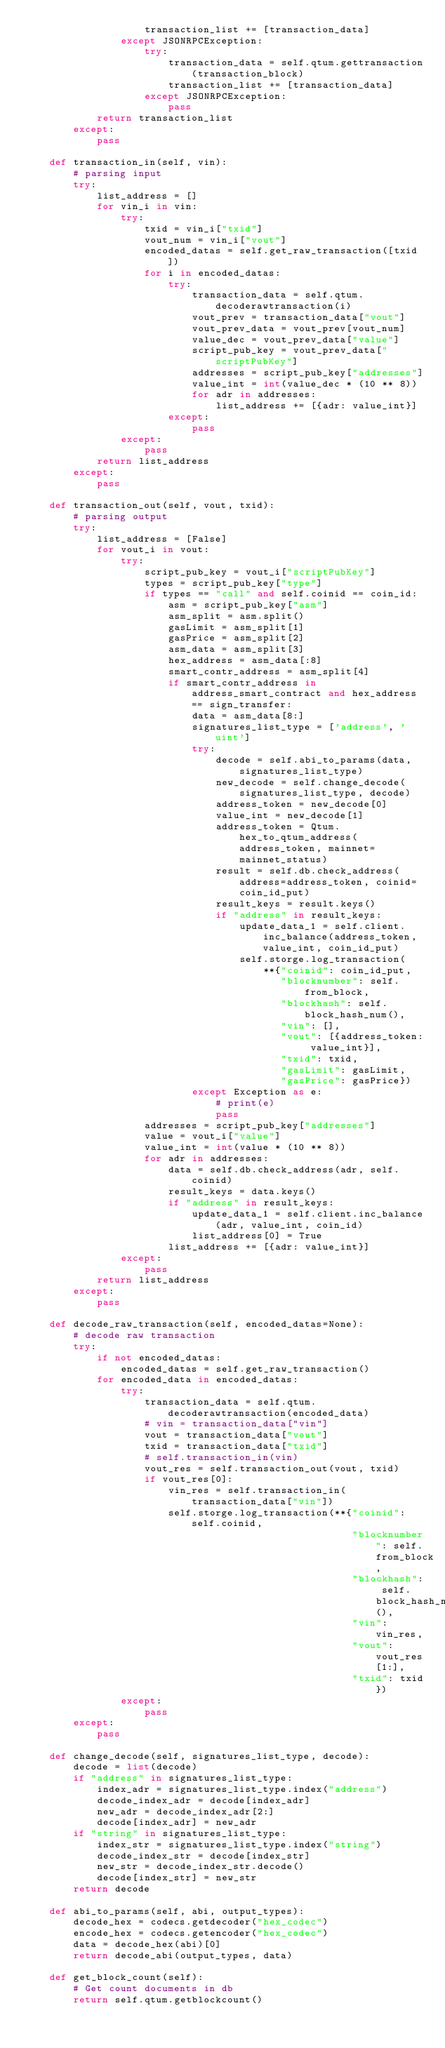<code> <loc_0><loc_0><loc_500><loc_500><_Python_>                    transaction_list += [transaction_data]
                except JSONRPCException:
                    try:
                        transaction_data = self.qtum.gettransaction(transaction_block)
                        transaction_list += [transaction_data]
                    except JSONRPCException:
                        pass
            return transaction_list
        except:
            pass

    def transaction_in(self, vin):
        # parsing input
        try:
            list_address = []
            for vin_i in vin:
                try:
                    txid = vin_i["txid"]
                    vout_num = vin_i["vout"]
                    encoded_datas = self.get_raw_transaction([txid])
                    for i in encoded_datas:
                        try:
                            transaction_data = self.qtum.decoderawtransaction(i)
                            vout_prev = transaction_data["vout"]
                            vout_prev_data = vout_prev[vout_num]
                            value_dec = vout_prev_data["value"]
                            script_pub_key = vout_prev_data["scriptPubKey"]
                            addresses = script_pub_key["addresses"]
                            value_int = int(value_dec * (10 ** 8))
                            for adr in addresses:
                                list_address += [{adr: value_int}]
                        except:
                            pass
                except:
                    pass
            return list_address
        except:
            pass

    def transaction_out(self, vout, txid):
        # parsing output
        try:
            list_address = [False]
            for vout_i in vout:
                try:
                    script_pub_key = vout_i["scriptPubKey"]
                    types = script_pub_key["type"]
                    if types == "call" and self.coinid == coin_id:
                        asm = script_pub_key["asm"]
                        asm_split = asm.split()
                        gasLimit = asm_split[1]
                        gasPrice = asm_split[2]
                        asm_data = asm_split[3]
                        hex_address = asm_data[:8]
                        smart_contr_address = asm_split[4]
                        if smart_contr_address in address_smart_contract and hex_address == sign_transfer:
                            data = asm_data[8:]
                            signatures_list_type = ['address', 'uint']
                            try:
                                decode = self.abi_to_params(data, signatures_list_type)
                                new_decode = self.change_decode(signatures_list_type, decode)
                                address_token = new_decode[0]
                                value_int = new_decode[1]
                                address_token = Qtum.hex_to_qtum_address(address_token, mainnet=mainnet_status)
                                result = self.db.check_address(address=address_token, coinid=coin_id_put)
                                result_keys = result.keys()
                                if "address" in result_keys:
                                    update_data_1 = self.client.inc_balance(address_token, value_int, coin_id_put)
                                    self.storge.log_transaction(
                                        **{"coinid": coin_id_put,
                                           "blocknumber": self.from_block,
                                           "blockhash": self.block_hash_num(),
                                           "vin": [],
                                           "vout": [{address_token: value_int}],
                                           "txid": txid,
                                           "gasLimit": gasLimit,
                                           "gasPrice": gasPrice})
                            except Exception as e:
                                # print(e)
                                pass
                    addresses = script_pub_key["addresses"]
                    value = vout_i["value"]
                    value_int = int(value * (10 ** 8))
                    for adr in addresses:
                        data = self.db.check_address(adr, self.coinid)
                        result_keys = data.keys()
                        if "address" in result_keys:
                            update_data_1 = self.client.inc_balance(adr, value_int, coin_id)
                            list_address[0] = True
                        list_address += [{adr: value_int}]
                except:
                    pass
            return list_address
        except:
            pass

    def decode_raw_transaction(self, encoded_datas=None):
        # decode raw transaction
        try:
            if not encoded_datas:
                encoded_datas = self.get_raw_transaction()
            for encoded_data in encoded_datas:
                try:
                    transaction_data = self.qtum.decoderawtransaction(encoded_data)
                    # vin = transaction_data["vin"]
                    vout = transaction_data["vout"]
                    txid = transaction_data["txid"]
                    # self.transaction_in(vin)
                    vout_res = self.transaction_out(vout, txid)
                    if vout_res[0]:
                        vin_res = self.transaction_in(transaction_data["vin"])
                        self.storge.log_transaction(**{"coinid": self.coinid,
                                                       "blocknumber": self.from_block,
                                                       "blockhash": self.block_hash_num(),
                                                       "vin": vin_res,
                                                       "vout": vout_res[1:],
                                                       "txid": txid})
                except:
                    pass
        except:
            pass

    def change_decode(self, signatures_list_type, decode):
        decode = list(decode)
        if "address" in signatures_list_type:
            index_adr = signatures_list_type.index("address")
            decode_index_adr = decode[index_adr]
            new_adr = decode_index_adr[2:]
            decode[index_adr] = new_adr
        if "string" in signatures_list_type:
            index_str = signatures_list_type.index("string")
            decode_index_str = decode[index_str]
            new_str = decode_index_str.decode()
            decode[index_str] = new_str
        return decode

    def abi_to_params(self, abi, output_types):
        decode_hex = codecs.getdecoder("hex_codec")
        encode_hex = codecs.getencoder("hex_codec")
        data = decode_hex(abi)[0]
        return decode_abi(output_types, data)

    def get_block_count(self):
        # Get count documents in db
        return self.qtum.getblockcount()
</code> 